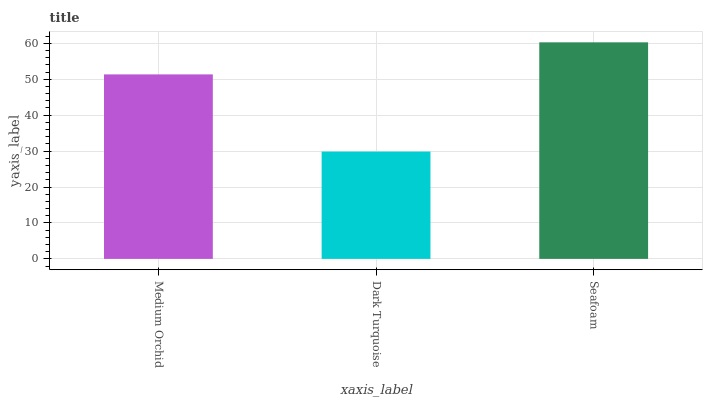Is Dark Turquoise the minimum?
Answer yes or no. Yes. Is Seafoam the maximum?
Answer yes or no. Yes. Is Seafoam the minimum?
Answer yes or no. No. Is Dark Turquoise the maximum?
Answer yes or no. No. Is Seafoam greater than Dark Turquoise?
Answer yes or no. Yes. Is Dark Turquoise less than Seafoam?
Answer yes or no. Yes. Is Dark Turquoise greater than Seafoam?
Answer yes or no. No. Is Seafoam less than Dark Turquoise?
Answer yes or no. No. Is Medium Orchid the high median?
Answer yes or no. Yes. Is Medium Orchid the low median?
Answer yes or no. Yes. Is Seafoam the high median?
Answer yes or no. No. Is Seafoam the low median?
Answer yes or no. No. 